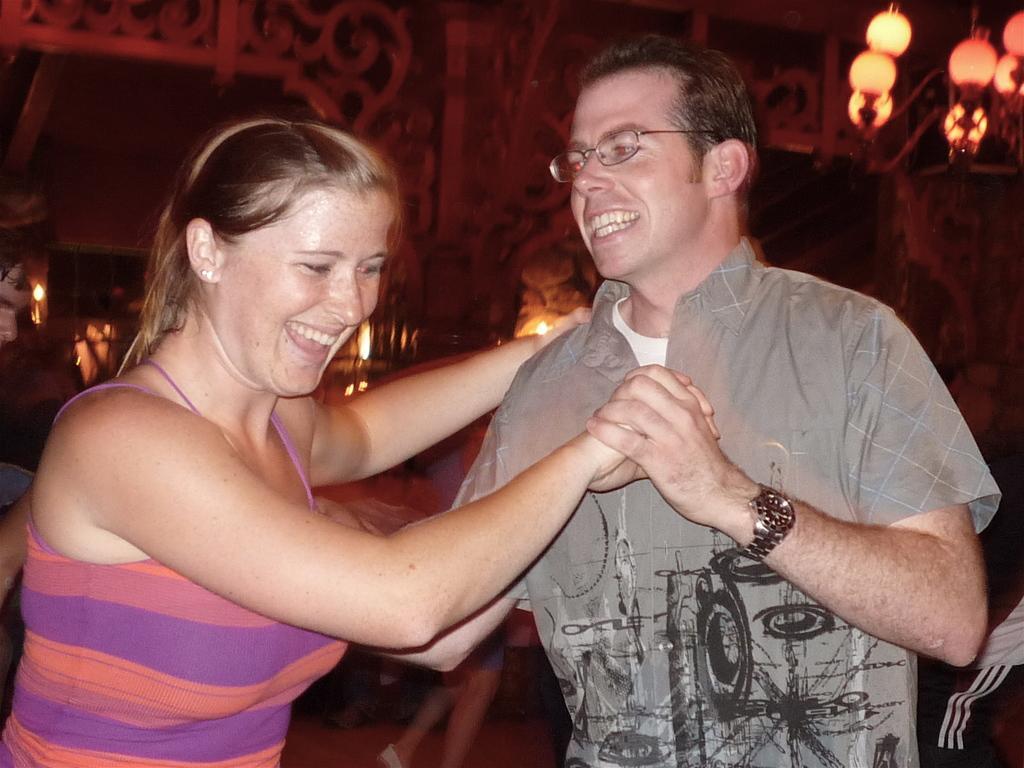Can you describe this image briefly? In this picture we can see a man wore spectacle, watch and holding a woman hand and both of them are smiling and in the background we can see lights. 